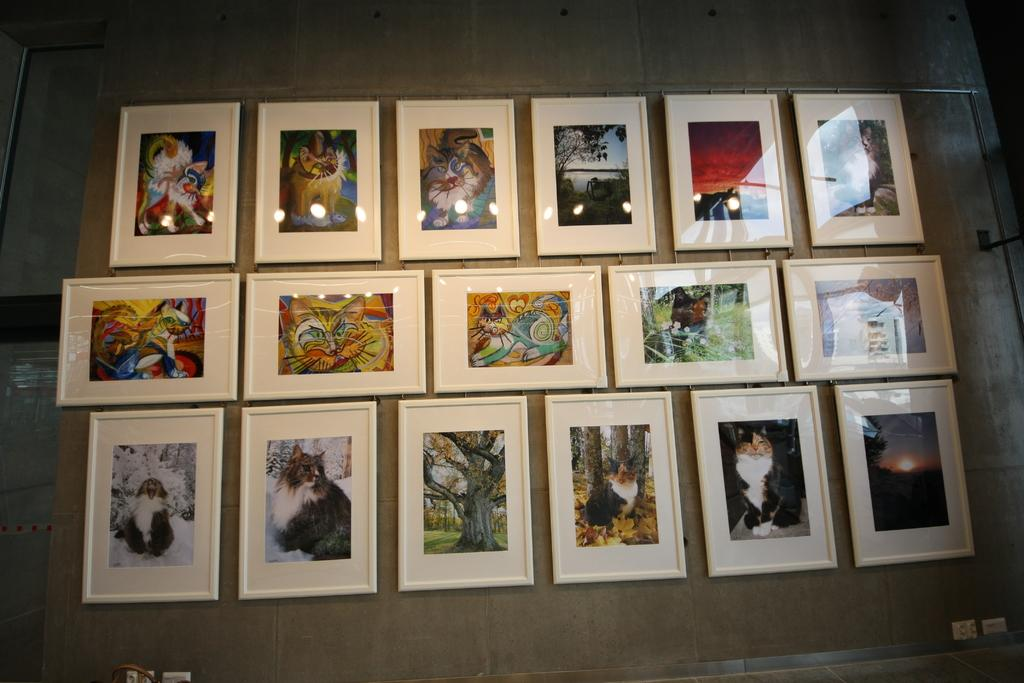What can be seen in the image in large quantities? There are many photo frames in the image. Where are the photo frames located? The photo frames are fixed on a wall. Which side of the image has a wall visible? There is a wall visible on the left side of the image. What type of teeth can be seen in the photo frames in the image? There are no teeth visible in the photo frames or the image; they contain photographs or other images. 